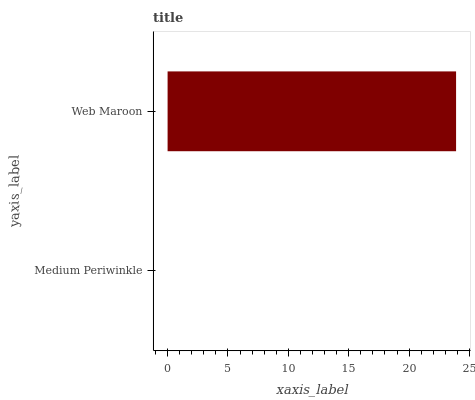Is Medium Periwinkle the minimum?
Answer yes or no. Yes. Is Web Maroon the maximum?
Answer yes or no. Yes. Is Web Maroon the minimum?
Answer yes or no. No. Is Web Maroon greater than Medium Periwinkle?
Answer yes or no. Yes. Is Medium Periwinkle less than Web Maroon?
Answer yes or no. Yes. Is Medium Periwinkle greater than Web Maroon?
Answer yes or no. No. Is Web Maroon less than Medium Periwinkle?
Answer yes or no. No. Is Web Maroon the high median?
Answer yes or no. Yes. Is Medium Periwinkle the low median?
Answer yes or no. Yes. Is Medium Periwinkle the high median?
Answer yes or no. No. Is Web Maroon the low median?
Answer yes or no. No. 